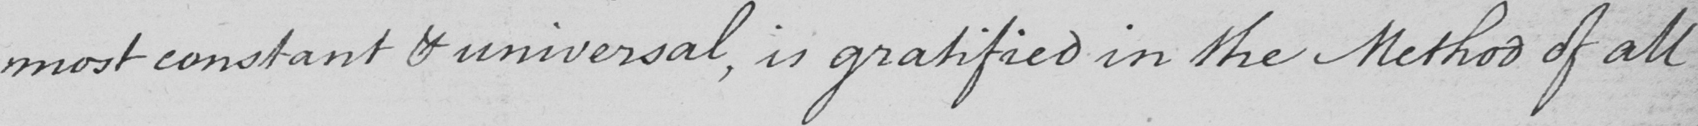Can you read and transcribe this handwriting? most constant & universal , is gratified in the Method of all 